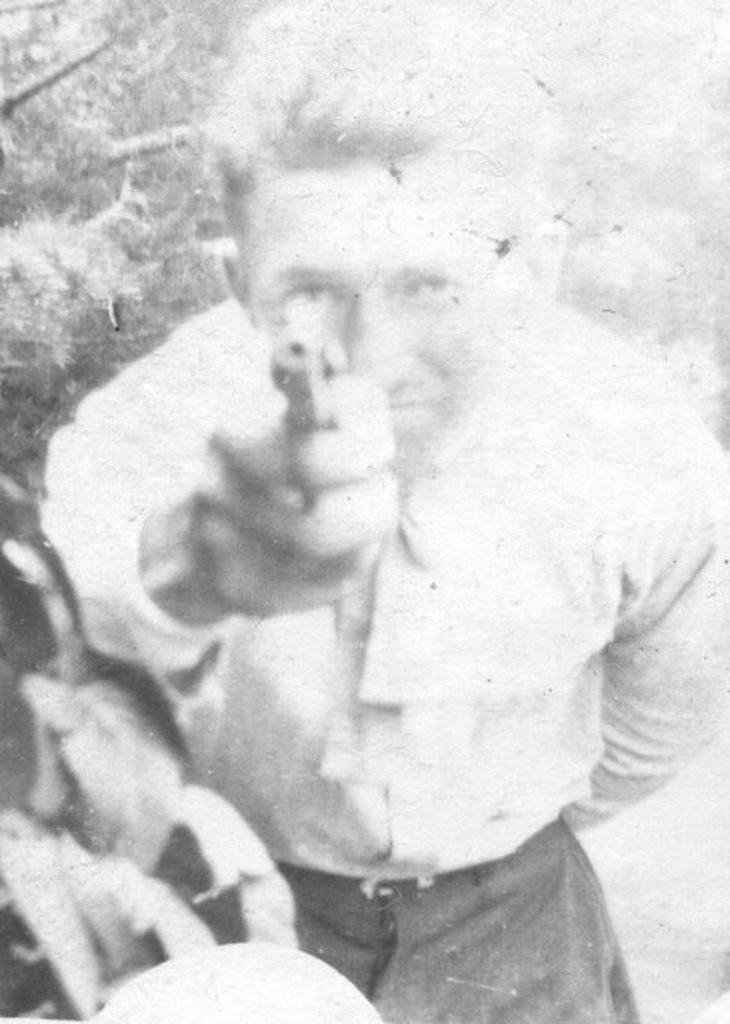What is the color scheme of the image? The image is black and white. Who is present in the image? There is a man in the image. What is the man holding in his hand? The man is holding an object in his hand. What can be seen in the background of the image? There are trees in the background of the image. How many sheep are visible in the image? There are no sheep present in the image. What book is the man reading in the image? The man is not reading a book in the image; he is holding an object in his hand. 